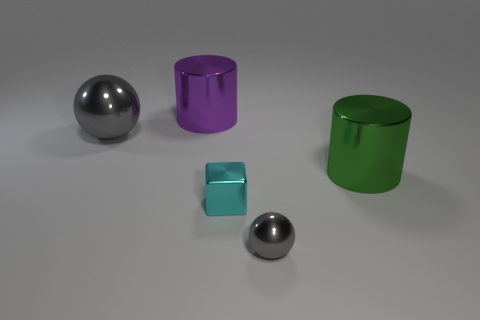Subtract all green cylinders. How many cylinders are left? 1 Subtract 1 cylinders. How many cylinders are left? 1 Add 4 shiny cylinders. How many objects exist? 9 Subtract 0 yellow spheres. How many objects are left? 5 Subtract all balls. How many objects are left? 3 Subtract all red cubes. Subtract all yellow cylinders. How many cubes are left? 1 Subtract all yellow balls. How many yellow cylinders are left? 0 Subtract all big cyan metallic blocks. Subtract all cyan cubes. How many objects are left? 4 Add 4 big gray shiny things. How many big gray shiny things are left? 5 Add 1 cyan metal balls. How many cyan metal balls exist? 1 